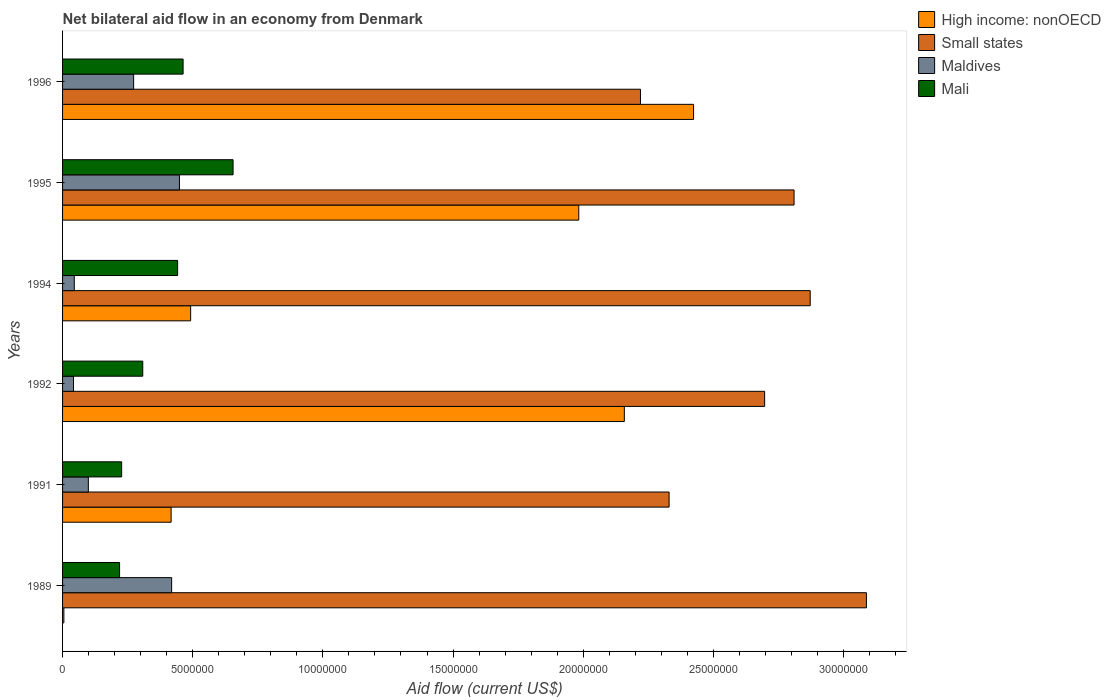How many different coloured bars are there?
Offer a terse response. 4. How many bars are there on the 1st tick from the top?
Offer a terse response. 4. How many bars are there on the 5th tick from the bottom?
Your answer should be compact. 4. What is the label of the 1st group of bars from the top?
Give a very brief answer. 1996. What is the net bilateral aid flow in Mali in 1995?
Give a very brief answer. 6.55e+06. Across all years, what is the maximum net bilateral aid flow in High income: nonOECD?
Make the answer very short. 2.42e+07. Across all years, what is the minimum net bilateral aid flow in High income: nonOECD?
Provide a short and direct response. 5.00e+04. In which year was the net bilateral aid flow in High income: nonOECD maximum?
Your response must be concise. 1996. In which year was the net bilateral aid flow in Mali minimum?
Provide a short and direct response. 1989. What is the total net bilateral aid flow in Maldives in the graph?
Give a very brief answer. 1.33e+07. What is the difference between the net bilateral aid flow in High income: nonOECD in 1991 and that in 1994?
Provide a succinct answer. -7.50e+05. What is the difference between the net bilateral aid flow in Small states in 1992 and the net bilateral aid flow in Mali in 1989?
Ensure brevity in your answer.  2.48e+07. What is the average net bilateral aid flow in Maldives per year?
Make the answer very short. 2.21e+06. In the year 1989, what is the difference between the net bilateral aid flow in Maldives and net bilateral aid flow in Mali?
Your answer should be very brief. 2.00e+06. What is the ratio of the net bilateral aid flow in Maldives in 1989 to that in 1996?
Make the answer very short. 1.53. Is the difference between the net bilateral aid flow in Maldives in 1989 and 1995 greater than the difference between the net bilateral aid flow in Mali in 1989 and 1995?
Provide a succinct answer. Yes. What is the difference between the highest and the second highest net bilateral aid flow in Small states?
Provide a short and direct response. 2.16e+06. What is the difference between the highest and the lowest net bilateral aid flow in Maldives?
Ensure brevity in your answer.  4.07e+06. In how many years, is the net bilateral aid flow in Small states greater than the average net bilateral aid flow in Small states taken over all years?
Give a very brief answer. 4. Is the sum of the net bilateral aid flow in Mali in 1994 and 1995 greater than the maximum net bilateral aid flow in Maldives across all years?
Offer a very short reply. Yes. Is it the case that in every year, the sum of the net bilateral aid flow in High income: nonOECD and net bilateral aid flow in Mali is greater than the sum of net bilateral aid flow in Maldives and net bilateral aid flow in Small states?
Offer a terse response. No. What does the 2nd bar from the top in 1995 represents?
Offer a terse response. Maldives. What does the 3rd bar from the bottom in 1991 represents?
Ensure brevity in your answer.  Maldives. Are all the bars in the graph horizontal?
Offer a very short reply. Yes. How many years are there in the graph?
Provide a short and direct response. 6. What is the difference between two consecutive major ticks on the X-axis?
Keep it short and to the point. 5.00e+06. Does the graph contain any zero values?
Ensure brevity in your answer.  No. Where does the legend appear in the graph?
Your answer should be very brief. Top right. How many legend labels are there?
Provide a short and direct response. 4. What is the title of the graph?
Make the answer very short. Net bilateral aid flow in an economy from Denmark. What is the Aid flow (current US$) in Small states in 1989?
Provide a succinct answer. 3.09e+07. What is the Aid flow (current US$) in Maldives in 1989?
Offer a very short reply. 4.19e+06. What is the Aid flow (current US$) in Mali in 1989?
Provide a succinct answer. 2.19e+06. What is the Aid flow (current US$) of High income: nonOECD in 1991?
Keep it short and to the point. 4.17e+06. What is the Aid flow (current US$) of Small states in 1991?
Give a very brief answer. 2.33e+07. What is the Aid flow (current US$) of Maldives in 1991?
Offer a very short reply. 9.90e+05. What is the Aid flow (current US$) in Mali in 1991?
Offer a terse response. 2.27e+06. What is the Aid flow (current US$) of High income: nonOECD in 1992?
Your response must be concise. 2.16e+07. What is the Aid flow (current US$) in Small states in 1992?
Make the answer very short. 2.70e+07. What is the Aid flow (current US$) of Mali in 1992?
Keep it short and to the point. 3.08e+06. What is the Aid flow (current US$) in High income: nonOECD in 1994?
Give a very brief answer. 4.92e+06. What is the Aid flow (current US$) in Small states in 1994?
Provide a short and direct response. 2.87e+07. What is the Aid flow (current US$) in Mali in 1994?
Make the answer very short. 4.42e+06. What is the Aid flow (current US$) in High income: nonOECD in 1995?
Keep it short and to the point. 1.98e+07. What is the Aid flow (current US$) in Small states in 1995?
Ensure brevity in your answer.  2.81e+07. What is the Aid flow (current US$) of Maldives in 1995?
Give a very brief answer. 4.49e+06. What is the Aid flow (current US$) in Mali in 1995?
Provide a short and direct response. 6.55e+06. What is the Aid flow (current US$) of High income: nonOECD in 1996?
Your answer should be compact. 2.42e+07. What is the Aid flow (current US$) of Small states in 1996?
Your answer should be very brief. 2.22e+07. What is the Aid flow (current US$) of Maldives in 1996?
Offer a very short reply. 2.73e+06. What is the Aid flow (current US$) in Mali in 1996?
Offer a terse response. 4.63e+06. Across all years, what is the maximum Aid flow (current US$) in High income: nonOECD?
Provide a short and direct response. 2.42e+07. Across all years, what is the maximum Aid flow (current US$) of Small states?
Offer a very short reply. 3.09e+07. Across all years, what is the maximum Aid flow (current US$) of Maldives?
Your answer should be very brief. 4.49e+06. Across all years, what is the maximum Aid flow (current US$) of Mali?
Offer a very short reply. 6.55e+06. Across all years, what is the minimum Aid flow (current US$) in High income: nonOECD?
Your answer should be very brief. 5.00e+04. Across all years, what is the minimum Aid flow (current US$) of Small states?
Give a very brief answer. 2.22e+07. Across all years, what is the minimum Aid flow (current US$) of Maldives?
Keep it short and to the point. 4.20e+05. Across all years, what is the minimum Aid flow (current US$) in Mali?
Offer a terse response. 2.19e+06. What is the total Aid flow (current US$) of High income: nonOECD in the graph?
Your answer should be compact. 7.48e+07. What is the total Aid flow (current US$) of Small states in the graph?
Keep it short and to the point. 1.60e+08. What is the total Aid flow (current US$) in Maldives in the graph?
Provide a short and direct response. 1.33e+07. What is the total Aid flow (current US$) of Mali in the graph?
Offer a very short reply. 2.31e+07. What is the difference between the Aid flow (current US$) in High income: nonOECD in 1989 and that in 1991?
Provide a short and direct response. -4.12e+06. What is the difference between the Aid flow (current US$) in Small states in 1989 and that in 1991?
Your response must be concise. 7.58e+06. What is the difference between the Aid flow (current US$) in Maldives in 1989 and that in 1991?
Your answer should be compact. 3.20e+06. What is the difference between the Aid flow (current US$) in Mali in 1989 and that in 1991?
Give a very brief answer. -8.00e+04. What is the difference between the Aid flow (current US$) in High income: nonOECD in 1989 and that in 1992?
Offer a terse response. -2.15e+07. What is the difference between the Aid flow (current US$) in Small states in 1989 and that in 1992?
Your response must be concise. 3.91e+06. What is the difference between the Aid flow (current US$) in Maldives in 1989 and that in 1992?
Give a very brief answer. 3.77e+06. What is the difference between the Aid flow (current US$) in Mali in 1989 and that in 1992?
Make the answer very short. -8.90e+05. What is the difference between the Aid flow (current US$) of High income: nonOECD in 1989 and that in 1994?
Your answer should be compact. -4.87e+06. What is the difference between the Aid flow (current US$) of Small states in 1989 and that in 1994?
Your answer should be compact. 2.16e+06. What is the difference between the Aid flow (current US$) in Maldives in 1989 and that in 1994?
Ensure brevity in your answer.  3.74e+06. What is the difference between the Aid flow (current US$) of Mali in 1989 and that in 1994?
Give a very brief answer. -2.23e+06. What is the difference between the Aid flow (current US$) of High income: nonOECD in 1989 and that in 1995?
Keep it short and to the point. -1.98e+07. What is the difference between the Aid flow (current US$) in Small states in 1989 and that in 1995?
Ensure brevity in your answer.  2.78e+06. What is the difference between the Aid flow (current US$) in Maldives in 1989 and that in 1995?
Keep it short and to the point. -3.00e+05. What is the difference between the Aid flow (current US$) in Mali in 1989 and that in 1995?
Offer a terse response. -4.36e+06. What is the difference between the Aid flow (current US$) of High income: nonOECD in 1989 and that in 1996?
Your response must be concise. -2.42e+07. What is the difference between the Aid flow (current US$) in Small states in 1989 and that in 1996?
Your answer should be very brief. 8.68e+06. What is the difference between the Aid flow (current US$) in Maldives in 1989 and that in 1996?
Keep it short and to the point. 1.46e+06. What is the difference between the Aid flow (current US$) in Mali in 1989 and that in 1996?
Your response must be concise. -2.44e+06. What is the difference between the Aid flow (current US$) in High income: nonOECD in 1991 and that in 1992?
Keep it short and to the point. -1.74e+07. What is the difference between the Aid flow (current US$) of Small states in 1991 and that in 1992?
Offer a very short reply. -3.67e+06. What is the difference between the Aid flow (current US$) in Maldives in 1991 and that in 1992?
Make the answer very short. 5.70e+05. What is the difference between the Aid flow (current US$) in Mali in 1991 and that in 1992?
Ensure brevity in your answer.  -8.10e+05. What is the difference between the Aid flow (current US$) in High income: nonOECD in 1991 and that in 1994?
Ensure brevity in your answer.  -7.50e+05. What is the difference between the Aid flow (current US$) in Small states in 1991 and that in 1994?
Keep it short and to the point. -5.42e+06. What is the difference between the Aid flow (current US$) of Maldives in 1991 and that in 1994?
Make the answer very short. 5.40e+05. What is the difference between the Aid flow (current US$) in Mali in 1991 and that in 1994?
Give a very brief answer. -2.15e+06. What is the difference between the Aid flow (current US$) in High income: nonOECD in 1991 and that in 1995?
Offer a terse response. -1.57e+07. What is the difference between the Aid flow (current US$) of Small states in 1991 and that in 1995?
Your response must be concise. -4.80e+06. What is the difference between the Aid flow (current US$) of Maldives in 1991 and that in 1995?
Make the answer very short. -3.50e+06. What is the difference between the Aid flow (current US$) in Mali in 1991 and that in 1995?
Provide a short and direct response. -4.28e+06. What is the difference between the Aid flow (current US$) of High income: nonOECD in 1991 and that in 1996?
Give a very brief answer. -2.01e+07. What is the difference between the Aid flow (current US$) of Small states in 1991 and that in 1996?
Your response must be concise. 1.10e+06. What is the difference between the Aid flow (current US$) of Maldives in 1991 and that in 1996?
Provide a short and direct response. -1.74e+06. What is the difference between the Aid flow (current US$) of Mali in 1991 and that in 1996?
Provide a succinct answer. -2.36e+06. What is the difference between the Aid flow (current US$) of High income: nonOECD in 1992 and that in 1994?
Offer a terse response. 1.67e+07. What is the difference between the Aid flow (current US$) of Small states in 1992 and that in 1994?
Provide a succinct answer. -1.75e+06. What is the difference between the Aid flow (current US$) in Maldives in 1992 and that in 1994?
Your response must be concise. -3.00e+04. What is the difference between the Aid flow (current US$) of Mali in 1992 and that in 1994?
Make the answer very short. -1.34e+06. What is the difference between the Aid flow (current US$) in High income: nonOECD in 1992 and that in 1995?
Ensure brevity in your answer.  1.75e+06. What is the difference between the Aid flow (current US$) of Small states in 1992 and that in 1995?
Your response must be concise. -1.13e+06. What is the difference between the Aid flow (current US$) of Maldives in 1992 and that in 1995?
Provide a short and direct response. -4.07e+06. What is the difference between the Aid flow (current US$) of Mali in 1992 and that in 1995?
Your answer should be very brief. -3.47e+06. What is the difference between the Aid flow (current US$) in High income: nonOECD in 1992 and that in 1996?
Your answer should be compact. -2.66e+06. What is the difference between the Aid flow (current US$) of Small states in 1992 and that in 1996?
Ensure brevity in your answer.  4.77e+06. What is the difference between the Aid flow (current US$) of Maldives in 1992 and that in 1996?
Offer a terse response. -2.31e+06. What is the difference between the Aid flow (current US$) of Mali in 1992 and that in 1996?
Give a very brief answer. -1.55e+06. What is the difference between the Aid flow (current US$) in High income: nonOECD in 1994 and that in 1995?
Your response must be concise. -1.49e+07. What is the difference between the Aid flow (current US$) in Small states in 1994 and that in 1995?
Offer a terse response. 6.20e+05. What is the difference between the Aid flow (current US$) in Maldives in 1994 and that in 1995?
Offer a very short reply. -4.04e+06. What is the difference between the Aid flow (current US$) in Mali in 1994 and that in 1995?
Offer a terse response. -2.13e+06. What is the difference between the Aid flow (current US$) of High income: nonOECD in 1994 and that in 1996?
Offer a terse response. -1.93e+07. What is the difference between the Aid flow (current US$) in Small states in 1994 and that in 1996?
Your response must be concise. 6.52e+06. What is the difference between the Aid flow (current US$) in Maldives in 1994 and that in 1996?
Offer a terse response. -2.28e+06. What is the difference between the Aid flow (current US$) in Mali in 1994 and that in 1996?
Keep it short and to the point. -2.10e+05. What is the difference between the Aid flow (current US$) of High income: nonOECD in 1995 and that in 1996?
Your response must be concise. -4.41e+06. What is the difference between the Aid flow (current US$) of Small states in 1995 and that in 1996?
Offer a very short reply. 5.90e+06. What is the difference between the Aid flow (current US$) of Maldives in 1995 and that in 1996?
Your answer should be very brief. 1.76e+06. What is the difference between the Aid flow (current US$) of Mali in 1995 and that in 1996?
Offer a terse response. 1.92e+06. What is the difference between the Aid flow (current US$) in High income: nonOECD in 1989 and the Aid flow (current US$) in Small states in 1991?
Provide a short and direct response. -2.32e+07. What is the difference between the Aid flow (current US$) of High income: nonOECD in 1989 and the Aid flow (current US$) of Maldives in 1991?
Keep it short and to the point. -9.40e+05. What is the difference between the Aid flow (current US$) of High income: nonOECD in 1989 and the Aid flow (current US$) of Mali in 1991?
Provide a short and direct response. -2.22e+06. What is the difference between the Aid flow (current US$) of Small states in 1989 and the Aid flow (current US$) of Maldives in 1991?
Make the answer very short. 2.99e+07. What is the difference between the Aid flow (current US$) of Small states in 1989 and the Aid flow (current US$) of Mali in 1991?
Provide a succinct answer. 2.86e+07. What is the difference between the Aid flow (current US$) in Maldives in 1989 and the Aid flow (current US$) in Mali in 1991?
Give a very brief answer. 1.92e+06. What is the difference between the Aid flow (current US$) in High income: nonOECD in 1989 and the Aid flow (current US$) in Small states in 1992?
Ensure brevity in your answer.  -2.69e+07. What is the difference between the Aid flow (current US$) in High income: nonOECD in 1989 and the Aid flow (current US$) in Maldives in 1992?
Provide a short and direct response. -3.70e+05. What is the difference between the Aid flow (current US$) of High income: nonOECD in 1989 and the Aid flow (current US$) of Mali in 1992?
Your answer should be very brief. -3.03e+06. What is the difference between the Aid flow (current US$) of Small states in 1989 and the Aid flow (current US$) of Maldives in 1992?
Make the answer very short. 3.05e+07. What is the difference between the Aid flow (current US$) of Small states in 1989 and the Aid flow (current US$) of Mali in 1992?
Provide a short and direct response. 2.78e+07. What is the difference between the Aid flow (current US$) of Maldives in 1989 and the Aid flow (current US$) of Mali in 1992?
Provide a succinct answer. 1.11e+06. What is the difference between the Aid flow (current US$) of High income: nonOECD in 1989 and the Aid flow (current US$) of Small states in 1994?
Provide a short and direct response. -2.87e+07. What is the difference between the Aid flow (current US$) in High income: nonOECD in 1989 and the Aid flow (current US$) in Maldives in 1994?
Your response must be concise. -4.00e+05. What is the difference between the Aid flow (current US$) of High income: nonOECD in 1989 and the Aid flow (current US$) of Mali in 1994?
Make the answer very short. -4.37e+06. What is the difference between the Aid flow (current US$) in Small states in 1989 and the Aid flow (current US$) in Maldives in 1994?
Your response must be concise. 3.04e+07. What is the difference between the Aid flow (current US$) in Small states in 1989 and the Aid flow (current US$) in Mali in 1994?
Offer a terse response. 2.65e+07. What is the difference between the Aid flow (current US$) of High income: nonOECD in 1989 and the Aid flow (current US$) of Small states in 1995?
Offer a terse response. -2.80e+07. What is the difference between the Aid flow (current US$) of High income: nonOECD in 1989 and the Aid flow (current US$) of Maldives in 1995?
Provide a short and direct response. -4.44e+06. What is the difference between the Aid flow (current US$) of High income: nonOECD in 1989 and the Aid flow (current US$) of Mali in 1995?
Ensure brevity in your answer.  -6.50e+06. What is the difference between the Aid flow (current US$) of Small states in 1989 and the Aid flow (current US$) of Maldives in 1995?
Give a very brief answer. 2.64e+07. What is the difference between the Aid flow (current US$) in Small states in 1989 and the Aid flow (current US$) in Mali in 1995?
Offer a very short reply. 2.43e+07. What is the difference between the Aid flow (current US$) of Maldives in 1989 and the Aid flow (current US$) of Mali in 1995?
Provide a succinct answer. -2.36e+06. What is the difference between the Aid flow (current US$) in High income: nonOECD in 1989 and the Aid flow (current US$) in Small states in 1996?
Keep it short and to the point. -2.22e+07. What is the difference between the Aid flow (current US$) in High income: nonOECD in 1989 and the Aid flow (current US$) in Maldives in 1996?
Keep it short and to the point. -2.68e+06. What is the difference between the Aid flow (current US$) of High income: nonOECD in 1989 and the Aid flow (current US$) of Mali in 1996?
Keep it short and to the point. -4.58e+06. What is the difference between the Aid flow (current US$) of Small states in 1989 and the Aid flow (current US$) of Maldives in 1996?
Provide a succinct answer. 2.82e+07. What is the difference between the Aid flow (current US$) in Small states in 1989 and the Aid flow (current US$) in Mali in 1996?
Give a very brief answer. 2.62e+07. What is the difference between the Aid flow (current US$) of Maldives in 1989 and the Aid flow (current US$) of Mali in 1996?
Provide a succinct answer. -4.40e+05. What is the difference between the Aid flow (current US$) of High income: nonOECD in 1991 and the Aid flow (current US$) of Small states in 1992?
Offer a terse response. -2.28e+07. What is the difference between the Aid flow (current US$) of High income: nonOECD in 1991 and the Aid flow (current US$) of Maldives in 1992?
Offer a very short reply. 3.75e+06. What is the difference between the Aid flow (current US$) of High income: nonOECD in 1991 and the Aid flow (current US$) of Mali in 1992?
Offer a terse response. 1.09e+06. What is the difference between the Aid flow (current US$) in Small states in 1991 and the Aid flow (current US$) in Maldives in 1992?
Give a very brief answer. 2.29e+07. What is the difference between the Aid flow (current US$) in Small states in 1991 and the Aid flow (current US$) in Mali in 1992?
Provide a succinct answer. 2.02e+07. What is the difference between the Aid flow (current US$) in Maldives in 1991 and the Aid flow (current US$) in Mali in 1992?
Provide a succinct answer. -2.09e+06. What is the difference between the Aid flow (current US$) in High income: nonOECD in 1991 and the Aid flow (current US$) in Small states in 1994?
Offer a terse response. -2.46e+07. What is the difference between the Aid flow (current US$) in High income: nonOECD in 1991 and the Aid flow (current US$) in Maldives in 1994?
Make the answer very short. 3.72e+06. What is the difference between the Aid flow (current US$) of Small states in 1991 and the Aid flow (current US$) of Maldives in 1994?
Offer a terse response. 2.28e+07. What is the difference between the Aid flow (current US$) of Small states in 1991 and the Aid flow (current US$) of Mali in 1994?
Give a very brief answer. 1.89e+07. What is the difference between the Aid flow (current US$) in Maldives in 1991 and the Aid flow (current US$) in Mali in 1994?
Keep it short and to the point. -3.43e+06. What is the difference between the Aid flow (current US$) of High income: nonOECD in 1991 and the Aid flow (current US$) of Small states in 1995?
Ensure brevity in your answer.  -2.39e+07. What is the difference between the Aid flow (current US$) in High income: nonOECD in 1991 and the Aid flow (current US$) in Maldives in 1995?
Provide a succinct answer. -3.20e+05. What is the difference between the Aid flow (current US$) of High income: nonOECD in 1991 and the Aid flow (current US$) of Mali in 1995?
Offer a very short reply. -2.38e+06. What is the difference between the Aid flow (current US$) in Small states in 1991 and the Aid flow (current US$) in Maldives in 1995?
Offer a very short reply. 1.88e+07. What is the difference between the Aid flow (current US$) in Small states in 1991 and the Aid flow (current US$) in Mali in 1995?
Make the answer very short. 1.68e+07. What is the difference between the Aid flow (current US$) in Maldives in 1991 and the Aid flow (current US$) in Mali in 1995?
Provide a short and direct response. -5.56e+06. What is the difference between the Aid flow (current US$) in High income: nonOECD in 1991 and the Aid flow (current US$) in Small states in 1996?
Your response must be concise. -1.80e+07. What is the difference between the Aid flow (current US$) of High income: nonOECD in 1991 and the Aid flow (current US$) of Maldives in 1996?
Ensure brevity in your answer.  1.44e+06. What is the difference between the Aid flow (current US$) in High income: nonOECD in 1991 and the Aid flow (current US$) in Mali in 1996?
Offer a very short reply. -4.60e+05. What is the difference between the Aid flow (current US$) in Small states in 1991 and the Aid flow (current US$) in Maldives in 1996?
Offer a very short reply. 2.06e+07. What is the difference between the Aid flow (current US$) of Small states in 1991 and the Aid flow (current US$) of Mali in 1996?
Give a very brief answer. 1.87e+07. What is the difference between the Aid flow (current US$) in Maldives in 1991 and the Aid flow (current US$) in Mali in 1996?
Ensure brevity in your answer.  -3.64e+06. What is the difference between the Aid flow (current US$) of High income: nonOECD in 1992 and the Aid flow (current US$) of Small states in 1994?
Make the answer very short. -7.14e+06. What is the difference between the Aid flow (current US$) of High income: nonOECD in 1992 and the Aid flow (current US$) of Maldives in 1994?
Your answer should be very brief. 2.11e+07. What is the difference between the Aid flow (current US$) of High income: nonOECD in 1992 and the Aid flow (current US$) of Mali in 1994?
Give a very brief answer. 1.72e+07. What is the difference between the Aid flow (current US$) in Small states in 1992 and the Aid flow (current US$) in Maldives in 1994?
Give a very brief answer. 2.65e+07. What is the difference between the Aid flow (current US$) of Small states in 1992 and the Aid flow (current US$) of Mali in 1994?
Provide a succinct answer. 2.26e+07. What is the difference between the Aid flow (current US$) in High income: nonOECD in 1992 and the Aid flow (current US$) in Small states in 1995?
Ensure brevity in your answer.  -6.52e+06. What is the difference between the Aid flow (current US$) in High income: nonOECD in 1992 and the Aid flow (current US$) in Maldives in 1995?
Provide a short and direct response. 1.71e+07. What is the difference between the Aid flow (current US$) in High income: nonOECD in 1992 and the Aid flow (current US$) in Mali in 1995?
Keep it short and to the point. 1.50e+07. What is the difference between the Aid flow (current US$) in Small states in 1992 and the Aid flow (current US$) in Maldives in 1995?
Give a very brief answer. 2.25e+07. What is the difference between the Aid flow (current US$) in Small states in 1992 and the Aid flow (current US$) in Mali in 1995?
Keep it short and to the point. 2.04e+07. What is the difference between the Aid flow (current US$) of Maldives in 1992 and the Aid flow (current US$) of Mali in 1995?
Offer a very short reply. -6.13e+06. What is the difference between the Aid flow (current US$) in High income: nonOECD in 1992 and the Aid flow (current US$) in Small states in 1996?
Your answer should be very brief. -6.20e+05. What is the difference between the Aid flow (current US$) of High income: nonOECD in 1992 and the Aid flow (current US$) of Maldives in 1996?
Give a very brief answer. 1.88e+07. What is the difference between the Aid flow (current US$) of High income: nonOECD in 1992 and the Aid flow (current US$) of Mali in 1996?
Provide a short and direct response. 1.70e+07. What is the difference between the Aid flow (current US$) in Small states in 1992 and the Aid flow (current US$) in Maldives in 1996?
Your answer should be compact. 2.42e+07. What is the difference between the Aid flow (current US$) in Small states in 1992 and the Aid flow (current US$) in Mali in 1996?
Offer a terse response. 2.23e+07. What is the difference between the Aid flow (current US$) of Maldives in 1992 and the Aid flow (current US$) of Mali in 1996?
Ensure brevity in your answer.  -4.21e+06. What is the difference between the Aid flow (current US$) of High income: nonOECD in 1994 and the Aid flow (current US$) of Small states in 1995?
Offer a terse response. -2.32e+07. What is the difference between the Aid flow (current US$) in High income: nonOECD in 1994 and the Aid flow (current US$) in Maldives in 1995?
Give a very brief answer. 4.30e+05. What is the difference between the Aid flow (current US$) of High income: nonOECD in 1994 and the Aid flow (current US$) of Mali in 1995?
Give a very brief answer. -1.63e+06. What is the difference between the Aid flow (current US$) of Small states in 1994 and the Aid flow (current US$) of Maldives in 1995?
Your answer should be compact. 2.42e+07. What is the difference between the Aid flow (current US$) in Small states in 1994 and the Aid flow (current US$) in Mali in 1995?
Make the answer very short. 2.22e+07. What is the difference between the Aid flow (current US$) of Maldives in 1994 and the Aid flow (current US$) of Mali in 1995?
Your answer should be very brief. -6.10e+06. What is the difference between the Aid flow (current US$) of High income: nonOECD in 1994 and the Aid flow (current US$) of Small states in 1996?
Your answer should be very brief. -1.73e+07. What is the difference between the Aid flow (current US$) of High income: nonOECD in 1994 and the Aid flow (current US$) of Maldives in 1996?
Your answer should be compact. 2.19e+06. What is the difference between the Aid flow (current US$) of Small states in 1994 and the Aid flow (current US$) of Maldives in 1996?
Offer a terse response. 2.60e+07. What is the difference between the Aid flow (current US$) in Small states in 1994 and the Aid flow (current US$) in Mali in 1996?
Offer a very short reply. 2.41e+07. What is the difference between the Aid flow (current US$) in Maldives in 1994 and the Aid flow (current US$) in Mali in 1996?
Provide a succinct answer. -4.18e+06. What is the difference between the Aid flow (current US$) of High income: nonOECD in 1995 and the Aid flow (current US$) of Small states in 1996?
Give a very brief answer. -2.37e+06. What is the difference between the Aid flow (current US$) of High income: nonOECD in 1995 and the Aid flow (current US$) of Maldives in 1996?
Your answer should be compact. 1.71e+07. What is the difference between the Aid flow (current US$) of High income: nonOECD in 1995 and the Aid flow (current US$) of Mali in 1996?
Your response must be concise. 1.52e+07. What is the difference between the Aid flow (current US$) of Small states in 1995 and the Aid flow (current US$) of Maldives in 1996?
Make the answer very short. 2.54e+07. What is the difference between the Aid flow (current US$) in Small states in 1995 and the Aid flow (current US$) in Mali in 1996?
Keep it short and to the point. 2.35e+07. What is the difference between the Aid flow (current US$) in Maldives in 1995 and the Aid flow (current US$) in Mali in 1996?
Provide a succinct answer. -1.40e+05. What is the average Aid flow (current US$) in High income: nonOECD per year?
Give a very brief answer. 1.25e+07. What is the average Aid flow (current US$) in Small states per year?
Offer a very short reply. 2.67e+07. What is the average Aid flow (current US$) of Maldives per year?
Ensure brevity in your answer.  2.21e+06. What is the average Aid flow (current US$) in Mali per year?
Your answer should be compact. 3.86e+06. In the year 1989, what is the difference between the Aid flow (current US$) of High income: nonOECD and Aid flow (current US$) of Small states?
Offer a very short reply. -3.08e+07. In the year 1989, what is the difference between the Aid flow (current US$) in High income: nonOECD and Aid flow (current US$) in Maldives?
Offer a very short reply. -4.14e+06. In the year 1989, what is the difference between the Aid flow (current US$) in High income: nonOECD and Aid flow (current US$) in Mali?
Offer a terse response. -2.14e+06. In the year 1989, what is the difference between the Aid flow (current US$) of Small states and Aid flow (current US$) of Maldives?
Your answer should be very brief. 2.67e+07. In the year 1989, what is the difference between the Aid flow (current US$) in Small states and Aid flow (current US$) in Mali?
Keep it short and to the point. 2.87e+07. In the year 1991, what is the difference between the Aid flow (current US$) in High income: nonOECD and Aid flow (current US$) in Small states?
Provide a short and direct response. -1.91e+07. In the year 1991, what is the difference between the Aid flow (current US$) of High income: nonOECD and Aid flow (current US$) of Maldives?
Provide a short and direct response. 3.18e+06. In the year 1991, what is the difference between the Aid flow (current US$) of High income: nonOECD and Aid flow (current US$) of Mali?
Your answer should be very brief. 1.90e+06. In the year 1991, what is the difference between the Aid flow (current US$) in Small states and Aid flow (current US$) in Maldives?
Your answer should be very brief. 2.23e+07. In the year 1991, what is the difference between the Aid flow (current US$) of Small states and Aid flow (current US$) of Mali?
Give a very brief answer. 2.10e+07. In the year 1991, what is the difference between the Aid flow (current US$) in Maldives and Aid flow (current US$) in Mali?
Offer a very short reply. -1.28e+06. In the year 1992, what is the difference between the Aid flow (current US$) of High income: nonOECD and Aid flow (current US$) of Small states?
Your answer should be compact. -5.39e+06. In the year 1992, what is the difference between the Aid flow (current US$) in High income: nonOECD and Aid flow (current US$) in Maldives?
Provide a short and direct response. 2.12e+07. In the year 1992, what is the difference between the Aid flow (current US$) in High income: nonOECD and Aid flow (current US$) in Mali?
Your answer should be very brief. 1.85e+07. In the year 1992, what is the difference between the Aid flow (current US$) of Small states and Aid flow (current US$) of Maldives?
Your answer should be very brief. 2.66e+07. In the year 1992, what is the difference between the Aid flow (current US$) in Small states and Aid flow (current US$) in Mali?
Ensure brevity in your answer.  2.39e+07. In the year 1992, what is the difference between the Aid flow (current US$) of Maldives and Aid flow (current US$) of Mali?
Give a very brief answer. -2.66e+06. In the year 1994, what is the difference between the Aid flow (current US$) of High income: nonOECD and Aid flow (current US$) of Small states?
Provide a succinct answer. -2.38e+07. In the year 1994, what is the difference between the Aid flow (current US$) in High income: nonOECD and Aid flow (current US$) in Maldives?
Make the answer very short. 4.47e+06. In the year 1994, what is the difference between the Aid flow (current US$) of High income: nonOECD and Aid flow (current US$) of Mali?
Ensure brevity in your answer.  5.00e+05. In the year 1994, what is the difference between the Aid flow (current US$) of Small states and Aid flow (current US$) of Maldives?
Offer a terse response. 2.83e+07. In the year 1994, what is the difference between the Aid flow (current US$) in Small states and Aid flow (current US$) in Mali?
Make the answer very short. 2.43e+07. In the year 1994, what is the difference between the Aid flow (current US$) in Maldives and Aid flow (current US$) in Mali?
Ensure brevity in your answer.  -3.97e+06. In the year 1995, what is the difference between the Aid flow (current US$) of High income: nonOECD and Aid flow (current US$) of Small states?
Make the answer very short. -8.27e+06. In the year 1995, what is the difference between the Aid flow (current US$) of High income: nonOECD and Aid flow (current US$) of Maldives?
Offer a very short reply. 1.53e+07. In the year 1995, what is the difference between the Aid flow (current US$) in High income: nonOECD and Aid flow (current US$) in Mali?
Your answer should be very brief. 1.33e+07. In the year 1995, what is the difference between the Aid flow (current US$) in Small states and Aid flow (current US$) in Maldives?
Your answer should be very brief. 2.36e+07. In the year 1995, what is the difference between the Aid flow (current US$) of Small states and Aid flow (current US$) of Mali?
Make the answer very short. 2.16e+07. In the year 1995, what is the difference between the Aid flow (current US$) in Maldives and Aid flow (current US$) in Mali?
Make the answer very short. -2.06e+06. In the year 1996, what is the difference between the Aid flow (current US$) in High income: nonOECD and Aid flow (current US$) in Small states?
Give a very brief answer. 2.04e+06. In the year 1996, what is the difference between the Aid flow (current US$) in High income: nonOECD and Aid flow (current US$) in Maldives?
Offer a very short reply. 2.15e+07. In the year 1996, what is the difference between the Aid flow (current US$) in High income: nonOECD and Aid flow (current US$) in Mali?
Your answer should be compact. 1.96e+07. In the year 1996, what is the difference between the Aid flow (current US$) of Small states and Aid flow (current US$) of Maldives?
Provide a succinct answer. 1.95e+07. In the year 1996, what is the difference between the Aid flow (current US$) of Small states and Aid flow (current US$) of Mali?
Keep it short and to the point. 1.76e+07. In the year 1996, what is the difference between the Aid flow (current US$) of Maldives and Aid flow (current US$) of Mali?
Provide a succinct answer. -1.90e+06. What is the ratio of the Aid flow (current US$) of High income: nonOECD in 1989 to that in 1991?
Make the answer very short. 0.01. What is the ratio of the Aid flow (current US$) in Small states in 1989 to that in 1991?
Make the answer very short. 1.33. What is the ratio of the Aid flow (current US$) in Maldives in 1989 to that in 1991?
Provide a succinct answer. 4.23. What is the ratio of the Aid flow (current US$) in Mali in 1989 to that in 1991?
Provide a succinct answer. 0.96. What is the ratio of the Aid flow (current US$) in High income: nonOECD in 1989 to that in 1992?
Ensure brevity in your answer.  0. What is the ratio of the Aid flow (current US$) of Small states in 1989 to that in 1992?
Make the answer very short. 1.15. What is the ratio of the Aid flow (current US$) of Maldives in 1989 to that in 1992?
Offer a very short reply. 9.98. What is the ratio of the Aid flow (current US$) in Mali in 1989 to that in 1992?
Your response must be concise. 0.71. What is the ratio of the Aid flow (current US$) of High income: nonOECD in 1989 to that in 1994?
Make the answer very short. 0.01. What is the ratio of the Aid flow (current US$) of Small states in 1989 to that in 1994?
Your response must be concise. 1.08. What is the ratio of the Aid flow (current US$) of Maldives in 1989 to that in 1994?
Keep it short and to the point. 9.31. What is the ratio of the Aid flow (current US$) in Mali in 1989 to that in 1994?
Give a very brief answer. 0.5. What is the ratio of the Aid flow (current US$) of High income: nonOECD in 1989 to that in 1995?
Provide a succinct answer. 0. What is the ratio of the Aid flow (current US$) in Small states in 1989 to that in 1995?
Make the answer very short. 1.1. What is the ratio of the Aid flow (current US$) of Maldives in 1989 to that in 1995?
Provide a succinct answer. 0.93. What is the ratio of the Aid flow (current US$) in Mali in 1989 to that in 1995?
Your response must be concise. 0.33. What is the ratio of the Aid flow (current US$) in High income: nonOECD in 1989 to that in 1996?
Offer a terse response. 0. What is the ratio of the Aid flow (current US$) in Small states in 1989 to that in 1996?
Your answer should be compact. 1.39. What is the ratio of the Aid flow (current US$) in Maldives in 1989 to that in 1996?
Give a very brief answer. 1.53. What is the ratio of the Aid flow (current US$) in Mali in 1989 to that in 1996?
Give a very brief answer. 0.47. What is the ratio of the Aid flow (current US$) of High income: nonOECD in 1991 to that in 1992?
Provide a succinct answer. 0.19. What is the ratio of the Aid flow (current US$) of Small states in 1991 to that in 1992?
Your answer should be compact. 0.86. What is the ratio of the Aid flow (current US$) in Maldives in 1991 to that in 1992?
Provide a short and direct response. 2.36. What is the ratio of the Aid flow (current US$) in Mali in 1991 to that in 1992?
Your response must be concise. 0.74. What is the ratio of the Aid flow (current US$) of High income: nonOECD in 1991 to that in 1994?
Ensure brevity in your answer.  0.85. What is the ratio of the Aid flow (current US$) of Small states in 1991 to that in 1994?
Provide a succinct answer. 0.81. What is the ratio of the Aid flow (current US$) in Maldives in 1991 to that in 1994?
Provide a succinct answer. 2.2. What is the ratio of the Aid flow (current US$) in Mali in 1991 to that in 1994?
Provide a succinct answer. 0.51. What is the ratio of the Aid flow (current US$) of High income: nonOECD in 1991 to that in 1995?
Your response must be concise. 0.21. What is the ratio of the Aid flow (current US$) in Small states in 1991 to that in 1995?
Your response must be concise. 0.83. What is the ratio of the Aid flow (current US$) of Maldives in 1991 to that in 1995?
Provide a succinct answer. 0.22. What is the ratio of the Aid flow (current US$) of Mali in 1991 to that in 1995?
Your response must be concise. 0.35. What is the ratio of the Aid flow (current US$) of High income: nonOECD in 1991 to that in 1996?
Provide a succinct answer. 0.17. What is the ratio of the Aid flow (current US$) of Small states in 1991 to that in 1996?
Your answer should be very brief. 1.05. What is the ratio of the Aid flow (current US$) in Maldives in 1991 to that in 1996?
Keep it short and to the point. 0.36. What is the ratio of the Aid flow (current US$) in Mali in 1991 to that in 1996?
Make the answer very short. 0.49. What is the ratio of the Aid flow (current US$) of High income: nonOECD in 1992 to that in 1994?
Offer a very short reply. 4.39. What is the ratio of the Aid flow (current US$) of Small states in 1992 to that in 1994?
Your answer should be compact. 0.94. What is the ratio of the Aid flow (current US$) of Mali in 1992 to that in 1994?
Your response must be concise. 0.7. What is the ratio of the Aid flow (current US$) of High income: nonOECD in 1992 to that in 1995?
Provide a succinct answer. 1.09. What is the ratio of the Aid flow (current US$) in Small states in 1992 to that in 1995?
Ensure brevity in your answer.  0.96. What is the ratio of the Aid flow (current US$) of Maldives in 1992 to that in 1995?
Ensure brevity in your answer.  0.09. What is the ratio of the Aid flow (current US$) of Mali in 1992 to that in 1995?
Ensure brevity in your answer.  0.47. What is the ratio of the Aid flow (current US$) of High income: nonOECD in 1992 to that in 1996?
Your answer should be compact. 0.89. What is the ratio of the Aid flow (current US$) of Small states in 1992 to that in 1996?
Make the answer very short. 1.21. What is the ratio of the Aid flow (current US$) of Maldives in 1992 to that in 1996?
Provide a short and direct response. 0.15. What is the ratio of the Aid flow (current US$) of Mali in 1992 to that in 1996?
Your response must be concise. 0.67. What is the ratio of the Aid flow (current US$) of High income: nonOECD in 1994 to that in 1995?
Your answer should be compact. 0.25. What is the ratio of the Aid flow (current US$) of Small states in 1994 to that in 1995?
Ensure brevity in your answer.  1.02. What is the ratio of the Aid flow (current US$) of Maldives in 1994 to that in 1995?
Your response must be concise. 0.1. What is the ratio of the Aid flow (current US$) of Mali in 1994 to that in 1995?
Make the answer very short. 0.67. What is the ratio of the Aid flow (current US$) of High income: nonOECD in 1994 to that in 1996?
Ensure brevity in your answer.  0.2. What is the ratio of the Aid flow (current US$) of Small states in 1994 to that in 1996?
Your response must be concise. 1.29. What is the ratio of the Aid flow (current US$) in Maldives in 1994 to that in 1996?
Offer a terse response. 0.16. What is the ratio of the Aid flow (current US$) in Mali in 1994 to that in 1996?
Keep it short and to the point. 0.95. What is the ratio of the Aid flow (current US$) in High income: nonOECD in 1995 to that in 1996?
Give a very brief answer. 0.82. What is the ratio of the Aid flow (current US$) of Small states in 1995 to that in 1996?
Provide a succinct answer. 1.27. What is the ratio of the Aid flow (current US$) of Maldives in 1995 to that in 1996?
Your response must be concise. 1.64. What is the ratio of the Aid flow (current US$) of Mali in 1995 to that in 1996?
Keep it short and to the point. 1.41. What is the difference between the highest and the second highest Aid flow (current US$) of High income: nonOECD?
Your response must be concise. 2.66e+06. What is the difference between the highest and the second highest Aid flow (current US$) in Small states?
Your answer should be compact. 2.16e+06. What is the difference between the highest and the second highest Aid flow (current US$) of Mali?
Offer a terse response. 1.92e+06. What is the difference between the highest and the lowest Aid flow (current US$) of High income: nonOECD?
Your answer should be compact. 2.42e+07. What is the difference between the highest and the lowest Aid flow (current US$) of Small states?
Ensure brevity in your answer.  8.68e+06. What is the difference between the highest and the lowest Aid flow (current US$) of Maldives?
Offer a terse response. 4.07e+06. What is the difference between the highest and the lowest Aid flow (current US$) of Mali?
Offer a very short reply. 4.36e+06. 